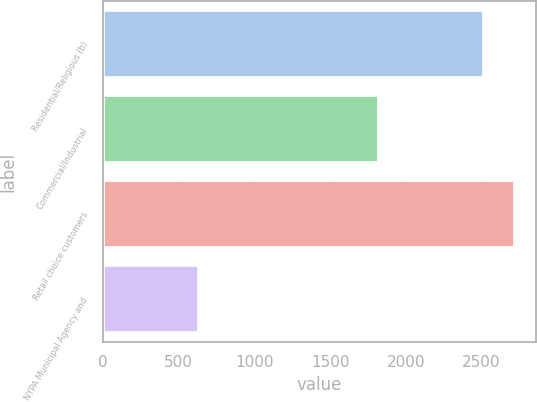Convert chart. <chart><loc_0><loc_0><loc_500><loc_500><bar_chart><fcel>Residential/Religious (b)<fcel>Commercial/Industrial<fcel>Retail choice customers<fcel>NYPA Municipal Agency and<nl><fcel>2515<fcel>1823<fcel>2722.9<fcel>633<nl></chart> 